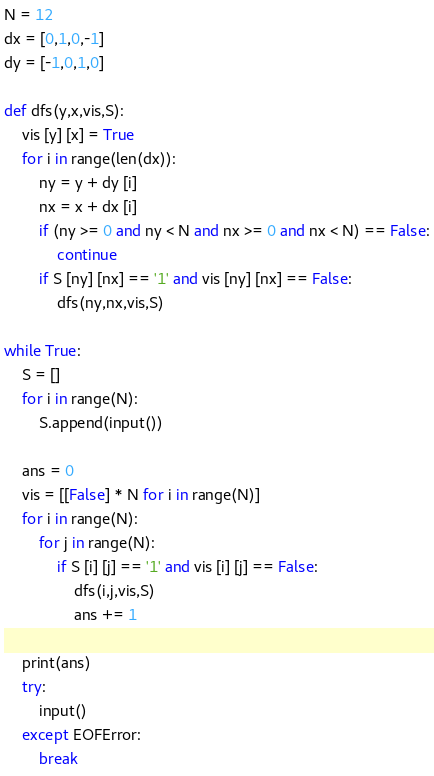Convert code to text. <code><loc_0><loc_0><loc_500><loc_500><_Python_>N = 12
dx = [0,1,0,-1]
dy = [-1,0,1,0]

def dfs(y,x,vis,S):
    vis [y] [x] = True
    for i in range(len(dx)):
        ny = y + dy [i]
        nx = x + dx [i]
        if (ny >= 0 and ny < N and nx >= 0 and nx < N) == False:
            continue
        if S [ny] [nx] == '1' and vis [ny] [nx] == False:
            dfs(ny,nx,vis,S)

while True:
    S = []
    for i in range(N):
        S.append(input())
    
    ans = 0
    vis = [[False] * N for i in range(N)]
    for i in range(N):
        for j in range(N):
            if S [i] [j] == '1' and vis [i] [j] == False:
                dfs(i,j,vis,S)
                ans += 1

    print(ans)
    try:
        input()
    except EOFError:
        break</code> 